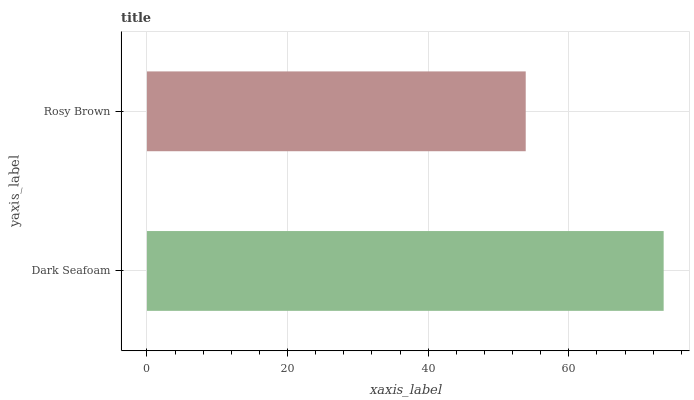Is Rosy Brown the minimum?
Answer yes or no. Yes. Is Dark Seafoam the maximum?
Answer yes or no. Yes. Is Rosy Brown the maximum?
Answer yes or no. No. Is Dark Seafoam greater than Rosy Brown?
Answer yes or no. Yes. Is Rosy Brown less than Dark Seafoam?
Answer yes or no. Yes. Is Rosy Brown greater than Dark Seafoam?
Answer yes or no. No. Is Dark Seafoam less than Rosy Brown?
Answer yes or no. No. Is Dark Seafoam the high median?
Answer yes or no. Yes. Is Rosy Brown the low median?
Answer yes or no. Yes. Is Rosy Brown the high median?
Answer yes or no. No. Is Dark Seafoam the low median?
Answer yes or no. No. 